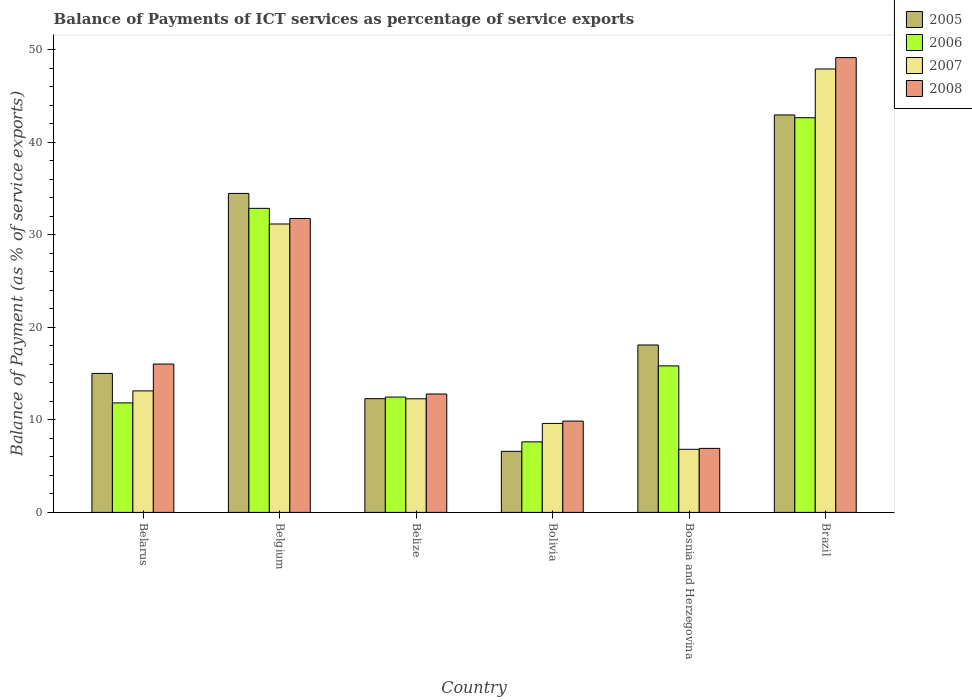How many groups of bars are there?
Provide a succinct answer. 6. How many bars are there on the 4th tick from the left?
Give a very brief answer. 4. How many bars are there on the 3rd tick from the right?
Keep it short and to the point. 4. What is the label of the 1st group of bars from the left?
Your answer should be very brief. Belarus. In how many cases, is the number of bars for a given country not equal to the number of legend labels?
Make the answer very short. 0. What is the balance of payments of ICT services in 2005 in Bosnia and Herzegovina?
Your response must be concise. 18.1. Across all countries, what is the maximum balance of payments of ICT services in 2006?
Make the answer very short. 42.67. Across all countries, what is the minimum balance of payments of ICT services in 2008?
Ensure brevity in your answer.  6.92. In which country was the balance of payments of ICT services in 2005 maximum?
Give a very brief answer. Brazil. In which country was the balance of payments of ICT services in 2005 minimum?
Make the answer very short. Bolivia. What is the total balance of payments of ICT services in 2008 in the graph?
Offer a terse response. 126.57. What is the difference between the balance of payments of ICT services in 2008 in Bosnia and Herzegovina and that in Brazil?
Provide a short and direct response. -42.25. What is the difference between the balance of payments of ICT services in 2007 in Belarus and the balance of payments of ICT services in 2005 in Brazil?
Offer a terse response. -29.83. What is the average balance of payments of ICT services in 2006 per country?
Keep it short and to the point. 20.55. What is the difference between the balance of payments of ICT services of/in 2008 and balance of payments of ICT services of/in 2005 in Belize?
Your response must be concise. 0.5. In how many countries, is the balance of payments of ICT services in 2005 greater than 28 %?
Make the answer very short. 2. What is the ratio of the balance of payments of ICT services in 2008 in Belarus to that in Bolivia?
Give a very brief answer. 1.62. What is the difference between the highest and the second highest balance of payments of ICT services in 2005?
Provide a short and direct response. 24.87. What is the difference between the highest and the lowest balance of payments of ICT services in 2006?
Keep it short and to the point. 35.04. In how many countries, is the balance of payments of ICT services in 2008 greater than the average balance of payments of ICT services in 2008 taken over all countries?
Your answer should be very brief. 2. Is it the case that in every country, the sum of the balance of payments of ICT services in 2008 and balance of payments of ICT services in 2007 is greater than the balance of payments of ICT services in 2006?
Offer a very short reply. No. How many bars are there?
Your response must be concise. 24. How many countries are there in the graph?
Make the answer very short. 6. Does the graph contain grids?
Your answer should be very brief. No. How many legend labels are there?
Offer a terse response. 4. How are the legend labels stacked?
Give a very brief answer. Vertical. What is the title of the graph?
Provide a succinct answer. Balance of Payments of ICT services as percentage of service exports. What is the label or title of the X-axis?
Give a very brief answer. Country. What is the label or title of the Y-axis?
Offer a very short reply. Balance of Payment (as % of service exports). What is the Balance of Payment (as % of service exports) of 2005 in Belarus?
Ensure brevity in your answer.  15.02. What is the Balance of Payment (as % of service exports) in 2006 in Belarus?
Your answer should be very brief. 11.84. What is the Balance of Payment (as % of service exports) of 2007 in Belarus?
Your response must be concise. 13.14. What is the Balance of Payment (as % of service exports) of 2008 in Belarus?
Offer a very short reply. 16.04. What is the Balance of Payment (as % of service exports) of 2005 in Belgium?
Offer a very short reply. 34.48. What is the Balance of Payment (as % of service exports) in 2006 in Belgium?
Offer a very short reply. 32.87. What is the Balance of Payment (as % of service exports) of 2007 in Belgium?
Offer a very short reply. 31.18. What is the Balance of Payment (as % of service exports) of 2008 in Belgium?
Keep it short and to the point. 31.77. What is the Balance of Payment (as % of service exports) in 2005 in Belize?
Provide a short and direct response. 12.29. What is the Balance of Payment (as % of service exports) in 2006 in Belize?
Your answer should be compact. 12.47. What is the Balance of Payment (as % of service exports) of 2007 in Belize?
Give a very brief answer. 12.28. What is the Balance of Payment (as % of service exports) in 2008 in Belize?
Make the answer very short. 12.8. What is the Balance of Payment (as % of service exports) of 2005 in Bolivia?
Ensure brevity in your answer.  6.6. What is the Balance of Payment (as % of service exports) of 2006 in Bolivia?
Give a very brief answer. 7.63. What is the Balance of Payment (as % of service exports) in 2007 in Bolivia?
Make the answer very short. 9.62. What is the Balance of Payment (as % of service exports) in 2008 in Bolivia?
Offer a terse response. 9.87. What is the Balance of Payment (as % of service exports) in 2005 in Bosnia and Herzegovina?
Provide a succinct answer. 18.1. What is the Balance of Payment (as % of service exports) in 2006 in Bosnia and Herzegovina?
Your response must be concise. 15.84. What is the Balance of Payment (as % of service exports) in 2007 in Bosnia and Herzegovina?
Keep it short and to the point. 6.82. What is the Balance of Payment (as % of service exports) in 2008 in Bosnia and Herzegovina?
Your answer should be very brief. 6.92. What is the Balance of Payment (as % of service exports) in 2005 in Brazil?
Offer a very short reply. 42.97. What is the Balance of Payment (as % of service exports) of 2006 in Brazil?
Ensure brevity in your answer.  42.67. What is the Balance of Payment (as % of service exports) of 2007 in Brazil?
Your answer should be very brief. 47.94. What is the Balance of Payment (as % of service exports) in 2008 in Brazil?
Offer a terse response. 49.17. Across all countries, what is the maximum Balance of Payment (as % of service exports) in 2005?
Offer a terse response. 42.97. Across all countries, what is the maximum Balance of Payment (as % of service exports) in 2006?
Provide a succinct answer. 42.67. Across all countries, what is the maximum Balance of Payment (as % of service exports) in 2007?
Provide a succinct answer. 47.94. Across all countries, what is the maximum Balance of Payment (as % of service exports) of 2008?
Your answer should be compact. 49.17. Across all countries, what is the minimum Balance of Payment (as % of service exports) in 2005?
Your answer should be very brief. 6.6. Across all countries, what is the minimum Balance of Payment (as % of service exports) of 2006?
Your answer should be very brief. 7.63. Across all countries, what is the minimum Balance of Payment (as % of service exports) in 2007?
Offer a very short reply. 6.82. Across all countries, what is the minimum Balance of Payment (as % of service exports) in 2008?
Your answer should be very brief. 6.92. What is the total Balance of Payment (as % of service exports) of 2005 in the graph?
Make the answer very short. 129.47. What is the total Balance of Payment (as % of service exports) of 2006 in the graph?
Your response must be concise. 123.31. What is the total Balance of Payment (as % of service exports) in 2007 in the graph?
Provide a short and direct response. 120.98. What is the total Balance of Payment (as % of service exports) of 2008 in the graph?
Offer a terse response. 126.57. What is the difference between the Balance of Payment (as % of service exports) in 2005 in Belarus and that in Belgium?
Offer a very short reply. -19.46. What is the difference between the Balance of Payment (as % of service exports) in 2006 in Belarus and that in Belgium?
Your response must be concise. -21.03. What is the difference between the Balance of Payment (as % of service exports) in 2007 in Belarus and that in Belgium?
Provide a short and direct response. -18.04. What is the difference between the Balance of Payment (as % of service exports) in 2008 in Belarus and that in Belgium?
Your answer should be compact. -15.73. What is the difference between the Balance of Payment (as % of service exports) in 2005 in Belarus and that in Belize?
Your answer should be very brief. 2.73. What is the difference between the Balance of Payment (as % of service exports) of 2006 in Belarus and that in Belize?
Offer a very short reply. -0.63. What is the difference between the Balance of Payment (as % of service exports) in 2007 in Belarus and that in Belize?
Make the answer very short. 0.85. What is the difference between the Balance of Payment (as % of service exports) in 2008 in Belarus and that in Belize?
Make the answer very short. 3.24. What is the difference between the Balance of Payment (as % of service exports) of 2005 in Belarus and that in Bolivia?
Your answer should be very brief. 8.42. What is the difference between the Balance of Payment (as % of service exports) of 2006 in Belarus and that in Bolivia?
Ensure brevity in your answer.  4.21. What is the difference between the Balance of Payment (as % of service exports) in 2007 in Belarus and that in Bolivia?
Offer a very short reply. 3.52. What is the difference between the Balance of Payment (as % of service exports) in 2008 in Belarus and that in Bolivia?
Make the answer very short. 6.17. What is the difference between the Balance of Payment (as % of service exports) of 2005 in Belarus and that in Bosnia and Herzegovina?
Offer a very short reply. -3.08. What is the difference between the Balance of Payment (as % of service exports) of 2006 in Belarus and that in Bosnia and Herzegovina?
Your response must be concise. -4. What is the difference between the Balance of Payment (as % of service exports) of 2007 in Belarus and that in Bosnia and Herzegovina?
Provide a short and direct response. 6.32. What is the difference between the Balance of Payment (as % of service exports) in 2008 in Belarus and that in Bosnia and Herzegovina?
Your response must be concise. 9.12. What is the difference between the Balance of Payment (as % of service exports) in 2005 in Belarus and that in Brazil?
Provide a succinct answer. -27.95. What is the difference between the Balance of Payment (as % of service exports) of 2006 in Belarus and that in Brazil?
Your answer should be very brief. -30.83. What is the difference between the Balance of Payment (as % of service exports) in 2007 in Belarus and that in Brazil?
Make the answer very short. -34.8. What is the difference between the Balance of Payment (as % of service exports) in 2008 in Belarus and that in Brazil?
Ensure brevity in your answer.  -33.13. What is the difference between the Balance of Payment (as % of service exports) of 2005 in Belgium and that in Belize?
Your response must be concise. 22.19. What is the difference between the Balance of Payment (as % of service exports) in 2006 in Belgium and that in Belize?
Provide a short and direct response. 20.4. What is the difference between the Balance of Payment (as % of service exports) of 2007 in Belgium and that in Belize?
Offer a very short reply. 18.9. What is the difference between the Balance of Payment (as % of service exports) of 2008 in Belgium and that in Belize?
Provide a succinct answer. 18.97. What is the difference between the Balance of Payment (as % of service exports) in 2005 in Belgium and that in Bolivia?
Keep it short and to the point. 27.88. What is the difference between the Balance of Payment (as % of service exports) in 2006 in Belgium and that in Bolivia?
Provide a succinct answer. 25.24. What is the difference between the Balance of Payment (as % of service exports) in 2007 in Belgium and that in Bolivia?
Make the answer very short. 21.56. What is the difference between the Balance of Payment (as % of service exports) of 2008 in Belgium and that in Bolivia?
Provide a succinct answer. 21.9. What is the difference between the Balance of Payment (as % of service exports) in 2005 in Belgium and that in Bosnia and Herzegovina?
Make the answer very short. 16.39. What is the difference between the Balance of Payment (as % of service exports) of 2006 in Belgium and that in Bosnia and Herzegovina?
Your answer should be very brief. 17.03. What is the difference between the Balance of Payment (as % of service exports) in 2007 in Belgium and that in Bosnia and Herzegovina?
Provide a succinct answer. 24.36. What is the difference between the Balance of Payment (as % of service exports) of 2008 in Belgium and that in Bosnia and Herzegovina?
Provide a succinct answer. 24.85. What is the difference between the Balance of Payment (as % of service exports) in 2005 in Belgium and that in Brazil?
Offer a very short reply. -8.49. What is the difference between the Balance of Payment (as % of service exports) of 2006 in Belgium and that in Brazil?
Provide a short and direct response. -9.8. What is the difference between the Balance of Payment (as % of service exports) in 2007 in Belgium and that in Brazil?
Ensure brevity in your answer.  -16.76. What is the difference between the Balance of Payment (as % of service exports) in 2008 in Belgium and that in Brazil?
Offer a terse response. -17.39. What is the difference between the Balance of Payment (as % of service exports) in 2005 in Belize and that in Bolivia?
Keep it short and to the point. 5.69. What is the difference between the Balance of Payment (as % of service exports) of 2006 in Belize and that in Bolivia?
Give a very brief answer. 4.84. What is the difference between the Balance of Payment (as % of service exports) in 2007 in Belize and that in Bolivia?
Provide a short and direct response. 2.66. What is the difference between the Balance of Payment (as % of service exports) of 2008 in Belize and that in Bolivia?
Offer a very short reply. 2.93. What is the difference between the Balance of Payment (as % of service exports) in 2005 in Belize and that in Bosnia and Herzegovina?
Offer a very short reply. -5.81. What is the difference between the Balance of Payment (as % of service exports) of 2006 in Belize and that in Bosnia and Herzegovina?
Provide a succinct answer. -3.37. What is the difference between the Balance of Payment (as % of service exports) of 2007 in Belize and that in Bosnia and Herzegovina?
Ensure brevity in your answer.  5.46. What is the difference between the Balance of Payment (as % of service exports) of 2008 in Belize and that in Bosnia and Herzegovina?
Give a very brief answer. 5.88. What is the difference between the Balance of Payment (as % of service exports) in 2005 in Belize and that in Brazil?
Offer a very short reply. -30.68. What is the difference between the Balance of Payment (as % of service exports) of 2006 in Belize and that in Brazil?
Your answer should be very brief. -30.2. What is the difference between the Balance of Payment (as % of service exports) of 2007 in Belize and that in Brazil?
Ensure brevity in your answer.  -35.65. What is the difference between the Balance of Payment (as % of service exports) in 2008 in Belize and that in Brazil?
Your answer should be very brief. -36.37. What is the difference between the Balance of Payment (as % of service exports) of 2005 in Bolivia and that in Bosnia and Herzegovina?
Provide a succinct answer. -11.5. What is the difference between the Balance of Payment (as % of service exports) in 2006 in Bolivia and that in Bosnia and Herzegovina?
Ensure brevity in your answer.  -8.21. What is the difference between the Balance of Payment (as % of service exports) of 2007 in Bolivia and that in Bosnia and Herzegovina?
Your answer should be very brief. 2.8. What is the difference between the Balance of Payment (as % of service exports) in 2008 in Bolivia and that in Bosnia and Herzegovina?
Your answer should be very brief. 2.95. What is the difference between the Balance of Payment (as % of service exports) of 2005 in Bolivia and that in Brazil?
Your response must be concise. -36.37. What is the difference between the Balance of Payment (as % of service exports) in 2006 in Bolivia and that in Brazil?
Offer a terse response. -35.04. What is the difference between the Balance of Payment (as % of service exports) in 2007 in Bolivia and that in Brazil?
Keep it short and to the point. -38.32. What is the difference between the Balance of Payment (as % of service exports) in 2008 in Bolivia and that in Brazil?
Your answer should be very brief. -39.3. What is the difference between the Balance of Payment (as % of service exports) in 2005 in Bosnia and Herzegovina and that in Brazil?
Give a very brief answer. -24.87. What is the difference between the Balance of Payment (as % of service exports) in 2006 in Bosnia and Herzegovina and that in Brazil?
Ensure brevity in your answer.  -26.83. What is the difference between the Balance of Payment (as % of service exports) in 2007 in Bosnia and Herzegovina and that in Brazil?
Offer a very short reply. -41.12. What is the difference between the Balance of Payment (as % of service exports) in 2008 in Bosnia and Herzegovina and that in Brazil?
Give a very brief answer. -42.25. What is the difference between the Balance of Payment (as % of service exports) in 2005 in Belarus and the Balance of Payment (as % of service exports) in 2006 in Belgium?
Offer a very short reply. -17.85. What is the difference between the Balance of Payment (as % of service exports) in 2005 in Belarus and the Balance of Payment (as % of service exports) in 2007 in Belgium?
Keep it short and to the point. -16.16. What is the difference between the Balance of Payment (as % of service exports) of 2005 in Belarus and the Balance of Payment (as % of service exports) of 2008 in Belgium?
Give a very brief answer. -16.75. What is the difference between the Balance of Payment (as % of service exports) in 2006 in Belarus and the Balance of Payment (as % of service exports) in 2007 in Belgium?
Your answer should be very brief. -19.34. What is the difference between the Balance of Payment (as % of service exports) in 2006 in Belarus and the Balance of Payment (as % of service exports) in 2008 in Belgium?
Offer a terse response. -19.93. What is the difference between the Balance of Payment (as % of service exports) of 2007 in Belarus and the Balance of Payment (as % of service exports) of 2008 in Belgium?
Offer a terse response. -18.64. What is the difference between the Balance of Payment (as % of service exports) in 2005 in Belarus and the Balance of Payment (as % of service exports) in 2006 in Belize?
Your response must be concise. 2.55. What is the difference between the Balance of Payment (as % of service exports) of 2005 in Belarus and the Balance of Payment (as % of service exports) of 2007 in Belize?
Your answer should be compact. 2.74. What is the difference between the Balance of Payment (as % of service exports) of 2005 in Belarus and the Balance of Payment (as % of service exports) of 2008 in Belize?
Provide a short and direct response. 2.23. What is the difference between the Balance of Payment (as % of service exports) of 2006 in Belarus and the Balance of Payment (as % of service exports) of 2007 in Belize?
Provide a short and direct response. -0.44. What is the difference between the Balance of Payment (as % of service exports) of 2006 in Belarus and the Balance of Payment (as % of service exports) of 2008 in Belize?
Make the answer very short. -0.96. What is the difference between the Balance of Payment (as % of service exports) of 2007 in Belarus and the Balance of Payment (as % of service exports) of 2008 in Belize?
Make the answer very short. 0.34. What is the difference between the Balance of Payment (as % of service exports) in 2005 in Belarus and the Balance of Payment (as % of service exports) in 2006 in Bolivia?
Ensure brevity in your answer.  7.4. What is the difference between the Balance of Payment (as % of service exports) of 2005 in Belarus and the Balance of Payment (as % of service exports) of 2007 in Bolivia?
Ensure brevity in your answer.  5.4. What is the difference between the Balance of Payment (as % of service exports) in 2005 in Belarus and the Balance of Payment (as % of service exports) in 2008 in Bolivia?
Provide a succinct answer. 5.15. What is the difference between the Balance of Payment (as % of service exports) of 2006 in Belarus and the Balance of Payment (as % of service exports) of 2007 in Bolivia?
Your answer should be very brief. 2.22. What is the difference between the Balance of Payment (as % of service exports) in 2006 in Belarus and the Balance of Payment (as % of service exports) in 2008 in Bolivia?
Your response must be concise. 1.97. What is the difference between the Balance of Payment (as % of service exports) in 2007 in Belarus and the Balance of Payment (as % of service exports) in 2008 in Bolivia?
Your answer should be very brief. 3.27. What is the difference between the Balance of Payment (as % of service exports) of 2005 in Belarus and the Balance of Payment (as % of service exports) of 2006 in Bosnia and Herzegovina?
Make the answer very short. -0.82. What is the difference between the Balance of Payment (as % of service exports) of 2005 in Belarus and the Balance of Payment (as % of service exports) of 2007 in Bosnia and Herzegovina?
Offer a terse response. 8.2. What is the difference between the Balance of Payment (as % of service exports) of 2005 in Belarus and the Balance of Payment (as % of service exports) of 2008 in Bosnia and Herzegovina?
Your response must be concise. 8.1. What is the difference between the Balance of Payment (as % of service exports) of 2006 in Belarus and the Balance of Payment (as % of service exports) of 2007 in Bosnia and Herzegovina?
Your answer should be very brief. 5.02. What is the difference between the Balance of Payment (as % of service exports) of 2006 in Belarus and the Balance of Payment (as % of service exports) of 2008 in Bosnia and Herzegovina?
Keep it short and to the point. 4.92. What is the difference between the Balance of Payment (as % of service exports) in 2007 in Belarus and the Balance of Payment (as % of service exports) in 2008 in Bosnia and Herzegovina?
Give a very brief answer. 6.22. What is the difference between the Balance of Payment (as % of service exports) of 2005 in Belarus and the Balance of Payment (as % of service exports) of 2006 in Brazil?
Give a very brief answer. -27.64. What is the difference between the Balance of Payment (as % of service exports) of 2005 in Belarus and the Balance of Payment (as % of service exports) of 2007 in Brazil?
Offer a very short reply. -32.91. What is the difference between the Balance of Payment (as % of service exports) of 2005 in Belarus and the Balance of Payment (as % of service exports) of 2008 in Brazil?
Keep it short and to the point. -34.14. What is the difference between the Balance of Payment (as % of service exports) in 2006 in Belarus and the Balance of Payment (as % of service exports) in 2007 in Brazil?
Your answer should be very brief. -36.1. What is the difference between the Balance of Payment (as % of service exports) in 2006 in Belarus and the Balance of Payment (as % of service exports) in 2008 in Brazil?
Offer a very short reply. -37.33. What is the difference between the Balance of Payment (as % of service exports) in 2007 in Belarus and the Balance of Payment (as % of service exports) in 2008 in Brazil?
Offer a very short reply. -36.03. What is the difference between the Balance of Payment (as % of service exports) in 2005 in Belgium and the Balance of Payment (as % of service exports) in 2006 in Belize?
Offer a terse response. 22.02. What is the difference between the Balance of Payment (as % of service exports) of 2005 in Belgium and the Balance of Payment (as % of service exports) of 2007 in Belize?
Ensure brevity in your answer.  22.2. What is the difference between the Balance of Payment (as % of service exports) of 2005 in Belgium and the Balance of Payment (as % of service exports) of 2008 in Belize?
Your answer should be compact. 21.69. What is the difference between the Balance of Payment (as % of service exports) in 2006 in Belgium and the Balance of Payment (as % of service exports) in 2007 in Belize?
Offer a very short reply. 20.59. What is the difference between the Balance of Payment (as % of service exports) of 2006 in Belgium and the Balance of Payment (as % of service exports) of 2008 in Belize?
Provide a short and direct response. 20.07. What is the difference between the Balance of Payment (as % of service exports) in 2007 in Belgium and the Balance of Payment (as % of service exports) in 2008 in Belize?
Your answer should be compact. 18.38. What is the difference between the Balance of Payment (as % of service exports) of 2005 in Belgium and the Balance of Payment (as % of service exports) of 2006 in Bolivia?
Keep it short and to the point. 26.86. What is the difference between the Balance of Payment (as % of service exports) in 2005 in Belgium and the Balance of Payment (as % of service exports) in 2007 in Bolivia?
Give a very brief answer. 24.87. What is the difference between the Balance of Payment (as % of service exports) of 2005 in Belgium and the Balance of Payment (as % of service exports) of 2008 in Bolivia?
Ensure brevity in your answer.  24.61. What is the difference between the Balance of Payment (as % of service exports) in 2006 in Belgium and the Balance of Payment (as % of service exports) in 2007 in Bolivia?
Ensure brevity in your answer.  23.25. What is the difference between the Balance of Payment (as % of service exports) in 2006 in Belgium and the Balance of Payment (as % of service exports) in 2008 in Bolivia?
Make the answer very short. 23. What is the difference between the Balance of Payment (as % of service exports) in 2007 in Belgium and the Balance of Payment (as % of service exports) in 2008 in Bolivia?
Offer a very short reply. 21.31. What is the difference between the Balance of Payment (as % of service exports) of 2005 in Belgium and the Balance of Payment (as % of service exports) of 2006 in Bosnia and Herzegovina?
Your response must be concise. 18.65. What is the difference between the Balance of Payment (as % of service exports) of 2005 in Belgium and the Balance of Payment (as % of service exports) of 2007 in Bosnia and Herzegovina?
Your answer should be compact. 27.66. What is the difference between the Balance of Payment (as % of service exports) in 2005 in Belgium and the Balance of Payment (as % of service exports) in 2008 in Bosnia and Herzegovina?
Your response must be concise. 27.56. What is the difference between the Balance of Payment (as % of service exports) of 2006 in Belgium and the Balance of Payment (as % of service exports) of 2007 in Bosnia and Herzegovina?
Provide a succinct answer. 26.05. What is the difference between the Balance of Payment (as % of service exports) in 2006 in Belgium and the Balance of Payment (as % of service exports) in 2008 in Bosnia and Herzegovina?
Offer a very short reply. 25.95. What is the difference between the Balance of Payment (as % of service exports) of 2007 in Belgium and the Balance of Payment (as % of service exports) of 2008 in Bosnia and Herzegovina?
Keep it short and to the point. 24.26. What is the difference between the Balance of Payment (as % of service exports) of 2005 in Belgium and the Balance of Payment (as % of service exports) of 2006 in Brazil?
Your answer should be compact. -8.18. What is the difference between the Balance of Payment (as % of service exports) in 2005 in Belgium and the Balance of Payment (as % of service exports) in 2007 in Brazil?
Offer a very short reply. -13.45. What is the difference between the Balance of Payment (as % of service exports) of 2005 in Belgium and the Balance of Payment (as % of service exports) of 2008 in Brazil?
Ensure brevity in your answer.  -14.68. What is the difference between the Balance of Payment (as % of service exports) of 2006 in Belgium and the Balance of Payment (as % of service exports) of 2007 in Brazil?
Your response must be concise. -15.07. What is the difference between the Balance of Payment (as % of service exports) in 2006 in Belgium and the Balance of Payment (as % of service exports) in 2008 in Brazil?
Your answer should be very brief. -16.3. What is the difference between the Balance of Payment (as % of service exports) in 2007 in Belgium and the Balance of Payment (as % of service exports) in 2008 in Brazil?
Provide a short and direct response. -17.99. What is the difference between the Balance of Payment (as % of service exports) of 2005 in Belize and the Balance of Payment (as % of service exports) of 2006 in Bolivia?
Your answer should be compact. 4.67. What is the difference between the Balance of Payment (as % of service exports) in 2005 in Belize and the Balance of Payment (as % of service exports) in 2007 in Bolivia?
Your answer should be compact. 2.67. What is the difference between the Balance of Payment (as % of service exports) in 2005 in Belize and the Balance of Payment (as % of service exports) in 2008 in Bolivia?
Offer a very short reply. 2.42. What is the difference between the Balance of Payment (as % of service exports) of 2006 in Belize and the Balance of Payment (as % of service exports) of 2007 in Bolivia?
Your answer should be very brief. 2.85. What is the difference between the Balance of Payment (as % of service exports) in 2006 in Belize and the Balance of Payment (as % of service exports) in 2008 in Bolivia?
Provide a succinct answer. 2.6. What is the difference between the Balance of Payment (as % of service exports) in 2007 in Belize and the Balance of Payment (as % of service exports) in 2008 in Bolivia?
Ensure brevity in your answer.  2.41. What is the difference between the Balance of Payment (as % of service exports) of 2005 in Belize and the Balance of Payment (as % of service exports) of 2006 in Bosnia and Herzegovina?
Keep it short and to the point. -3.55. What is the difference between the Balance of Payment (as % of service exports) in 2005 in Belize and the Balance of Payment (as % of service exports) in 2007 in Bosnia and Herzegovina?
Give a very brief answer. 5.47. What is the difference between the Balance of Payment (as % of service exports) of 2005 in Belize and the Balance of Payment (as % of service exports) of 2008 in Bosnia and Herzegovina?
Provide a short and direct response. 5.37. What is the difference between the Balance of Payment (as % of service exports) in 2006 in Belize and the Balance of Payment (as % of service exports) in 2007 in Bosnia and Herzegovina?
Provide a succinct answer. 5.65. What is the difference between the Balance of Payment (as % of service exports) in 2006 in Belize and the Balance of Payment (as % of service exports) in 2008 in Bosnia and Herzegovina?
Your answer should be compact. 5.55. What is the difference between the Balance of Payment (as % of service exports) of 2007 in Belize and the Balance of Payment (as % of service exports) of 2008 in Bosnia and Herzegovina?
Your response must be concise. 5.36. What is the difference between the Balance of Payment (as % of service exports) in 2005 in Belize and the Balance of Payment (as % of service exports) in 2006 in Brazil?
Provide a short and direct response. -30.37. What is the difference between the Balance of Payment (as % of service exports) in 2005 in Belize and the Balance of Payment (as % of service exports) in 2007 in Brazil?
Make the answer very short. -35.64. What is the difference between the Balance of Payment (as % of service exports) of 2005 in Belize and the Balance of Payment (as % of service exports) of 2008 in Brazil?
Your answer should be compact. -36.87. What is the difference between the Balance of Payment (as % of service exports) in 2006 in Belize and the Balance of Payment (as % of service exports) in 2007 in Brazil?
Your answer should be very brief. -35.47. What is the difference between the Balance of Payment (as % of service exports) in 2006 in Belize and the Balance of Payment (as % of service exports) in 2008 in Brazil?
Make the answer very short. -36.7. What is the difference between the Balance of Payment (as % of service exports) of 2007 in Belize and the Balance of Payment (as % of service exports) of 2008 in Brazil?
Your answer should be compact. -36.88. What is the difference between the Balance of Payment (as % of service exports) of 2005 in Bolivia and the Balance of Payment (as % of service exports) of 2006 in Bosnia and Herzegovina?
Provide a succinct answer. -9.24. What is the difference between the Balance of Payment (as % of service exports) in 2005 in Bolivia and the Balance of Payment (as % of service exports) in 2007 in Bosnia and Herzegovina?
Make the answer very short. -0.22. What is the difference between the Balance of Payment (as % of service exports) in 2005 in Bolivia and the Balance of Payment (as % of service exports) in 2008 in Bosnia and Herzegovina?
Give a very brief answer. -0.32. What is the difference between the Balance of Payment (as % of service exports) in 2006 in Bolivia and the Balance of Payment (as % of service exports) in 2007 in Bosnia and Herzegovina?
Keep it short and to the point. 0.8. What is the difference between the Balance of Payment (as % of service exports) of 2006 in Bolivia and the Balance of Payment (as % of service exports) of 2008 in Bosnia and Herzegovina?
Make the answer very short. 0.71. What is the difference between the Balance of Payment (as % of service exports) of 2007 in Bolivia and the Balance of Payment (as % of service exports) of 2008 in Bosnia and Herzegovina?
Your response must be concise. 2.7. What is the difference between the Balance of Payment (as % of service exports) in 2005 in Bolivia and the Balance of Payment (as % of service exports) in 2006 in Brazil?
Provide a succinct answer. -36.07. What is the difference between the Balance of Payment (as % of service exports) in 2005 in Bolivia and the Balance of Payment (as % of service exports) in 2007 in Brazil?
Your answer should be compact. -41.34. What is the difference between the Balance of Payment (as % of service exports) of 2005 in Bolivia and the Balance of Payment (as % of service exports) of 2008 in Brazil?
Keep it short and to the point. -42.57. What is the difference between the Balance of Payment (as % of service exports) of 2006 in Bolivia and the Balance of Payment (as % of service exports) of 2007 in Brazil?
Make the answer very short. -40.31. What is the difference between the Balance of Payment (as % of service exports) in 2006 in Bolivia and the Balance of Payment (as % of service exports) in 2008 in Brazil?
Ensure brevity in your answer.  -41.54. What is the difference between the Balance of Payment (as % of service exports) in 2007 in Bolivia and the Balance of Payment (as % of service exports) in 2008 in Brazil?
Make the answer very short. -39.55. What is the difference between the Balance of Payment (as % of service exports) of 2005 in Bosnia and Herzegovina and the Balance of Payment (as % of service exports) of 2006 in Brazil?
Your response must be concise. -24.57. What is the difference between the Balance of Payment (as % of service exports) of 2005 in Bosnia and Herzegovina and the Balance of Payment (as % of service exports) of 2007 in Brazil?
Make the answer very short. -29.84. What is the difference between the Balance of Payment (as % of service exports) in 2005 in Bosnia and Herzegovina and the Balance of Payment (as % of service exports) in 2008 in Brazil?
Your response must be concise. -31.07. What is the difference between the Balance of Payment (as % of service exports) of 2006 in Bosnia and Herzegovina and the Balance of Payment (as % of service exports) of 2007 in Brazil?
Make the answer very short. -32.1. What is the difference between the Balance of Payment (as % of service exports) in 2006 in Bosnia and Herzegovina and the Balance of Payment (as % of service exports) in 2008 in Brazil?
Offer a very short reply. -33.33. What is the difference between the Balance of Payment (as % of service exports) of 2007 in Bosnia and Herzegovina and the Balance of Payment (as % of service exports) of 2008 in Brazil?
Offer a terse response. -42.34. What is the average Balance of Payment (as % of service exports) of 2005 per country?
Ensure brevity in your answer.  21.58. What is the average Balance of Payment (as % of service exports) in 2006 per country?
Keep it short and to the point. 20.55. What is the average Balance of Payment (as % of service exports) of 2007 per country?
Your answer should be very brief. 20.16. What is the average Balance of Payment (as % of service exports) of 2008 per country?
Provide a short and direct response. 21.09. What is the difference between the Balance of Payment (as % of service exports) of 2005 and Balance of Payment (as % of service exports) of 2006 in Belarus?
Offer a very short reply. 3.19. What is the difference between the Balance of Payment (as % of service exports) of 2005 and Balance of Payment (as % of service exports) of 2007 in Belarus?
Your response must be concise. 1.89. What is the difference between the Balance of Payment (as % of service exports) in 2005 and Balance of Payment (as % of service exports) in 2008 in Belarus?
Provide a short and direct response. -1.01. What is the difference between the Balance of Payment (as % of service exports) in 2006 and Balance of Payment (as % of service exports) in 2007 in Belarus?
Keep it short and to the point. -1.3. What is the difference between the Balance of Payment (as % of service exports) of 2006 and Balance of Payment (as % of service exports) of 2008 in Belarus?
Your answer should be compact. -4.2. What is the difference between the Balance of Payment (as % of service exports) of 2007 and Balance of Payment (as % of service exports) of 2008 in Belarus?
Your response must be concise. -2.9. What is the difference between the Balance of Payment (as % of service exports) in 2005 and Balance of Payment (as % of service exports) in 2006 in Belgium?
Your answer should be very brief. 1.61. What is the difference between the Balance of Payment (as % of service exports) in 2005 and Balance of Payment (as % of service exports) in 2007 in Belgium?
Ensure brevity in your answer.  3.31. What is the difference between the Balance of Payment (as % of service exports) in 2005 and Balance of Payment (as % of service exports) in 2008 in Belgium?
Your answer should be very brief. 2.71. What is the difference between the Balance of Payment (as % of service exports) of 2006 and Balance of Payment (as % of service exports) of 2007 in Belgium?
Your response must be concise. 1.69. What is the difference between the Balance of Payment (as % of service exports) of 2006 and Balance of Payment (as % of service exports) of 2008 in Belgium?
Ensure brevity in your answer.  1.1. What is the difference between the Balance of Payment (as % of service exports) in 2007 and Balance of Payment (as % of service exports) in 2008 in Belgium?
Provide a succinct answer. -0.59. What is the difference between the Balance of Payment (as % of service exports) of 2005 and Balance of Payment (as % of service exports) of 2006 in Belize?
Provide a short and direct response. -0.18. What is the difference between the Balance of Payment (as % of service exports) in 2005 and Balance of Payment (as % of service exports) in 2007 in Belize?
Keep it short and to the point. 0.01. What is the difference between the Balance of Payment (as % of service exports) in 2005 and Balance of Payment (as % of service exports) in 2008 in Belize?
Provide a short and direct response. -0.5. What is the difference between the Balance of Payment (as % of service exports) in 2006 and Balance of Payment (as % of service exports) in 2007 in Belize?
Your answer should be compact. 0.19. What is the difference between the Balance of Payment (as % of service exports) in 2006 and Balance of Payment (as % of service exports) in 2008 in Belize?
Provide a short and direct response. -0.33. What is the difference between the Balance of Payment (as % of service exports) of 2007 and Balance of Payment (as % of service exports) of 2008 in Belize?
Offer a very short reply. -0.52. What is the difference between the Balance of Payment (as % of service exports) in 2005 and Balance of Payment (as % of service exports) in 2006 in Bolivia?
Offer a very short reply. -1.03. What is the difference between the Balance of Payment (as % of service exports) of 2005 and Balance of Payment (as % of service exports) of 2007 in Bolivia?
Offer a terse response. -3.02. What is the difference between the Balance of Payment (as % of service exports) of 2005 and Balance of Payment (as % of service exports) of 2008 in Bolivia?
Your answer should be compact. -3.27. What is the difference between the Balance of Payment (as % of service exports) of 2006 and Balance of Payment (as % of service exports) of 2007 in Bolivia?
Give a very brief answer. -1.99. What is the difference between the Balance of Payment (as % of service exports) in 2006 and Balance of Payment (as % of service exports) in 2008 in Bolivia?
Your response must be concise. -2.24. What is the difference between the Balance of Payment (as % of service exports) in 2007 and Balance of Payment (as % of service exports) in 2008 in Bolivia?
Offer a very short reply. -0.25. What is the difference between the Balance of Payment (as % of service exports) of 2005 and Balance of Payment (as % of service exports) of 2006 in Bosnia and Herzegovina?
Give a very brief answer. 2.26. What is the difference between the Balance of Payment (as % of service exports) of 2005 and Balance of Payment (as % of service exports) of 2007 in Bosnia and Herzegovina?
Provide a short and direct response. 11.28. What is the difference between the Balance of Payment (as % of service exports) in 2005 and Balance of Payment (as % of service exports) in 2008 in Bosnia and Herzegovina?
Give a very brief answer. 11.18. What is the difference between the Balance of Payment (as % of service exports) in 2006 and Balance of Payment (as % of service exports) in 2007 in Bosnia and Herzegovina?
Your answer should be compact. 9.02. What is the difference between the Balance of Payment (as % of service exports) in 2006 and Balance of Payment (as % of service exports) in 2008 in Bosnia and Herzegovina?
Your response must be concise. 8.92. What is the difference between the Balance of Payment (as % of service exports) of 2007 and Balance of Payment (as % of service exports) of 2008 in Bosnia and Herzegovina?
Provide a succinct answer. -0.1. What is the difference between the Balance of Payment (as % of service exports) in 2005 and Balance of Payment (as % of service exports) in 2006 in Brazil?
Offer a terse response. 0.3. What is the difference between the Balance of Payment (as % of service exports) of 2005 and Balance of Payment (as % of service exports) of 2007 in Brazil?
Provide a short and direct response. -4.97. What is the difference between the Balance of Payment (as % of service exports) of 2005 and Balance of Payment (as % of service exports) of 2008 in Brazil?
Make the answer very short. -6.2. What is the difference between the Balance of Payment (as % of service exports) in 2006 and Balance of Payment (as % of service exports) in 2007 in Brazil?
Offer a terse response. -5.27. What is the difference between the Balance of Payment (as % of service exports) in 2006 and Balance of Payment (as % of service exports) in 2008 in Brazil?
Offer a very short reply. -6.5. What is the difference between the Balance of Payment (as % of service exports) of 2007 and Balance of Payment (as % of service exports) of 2008 in Brazil?
Offer a very short reply. -1.23. What is the ratio of the Balance of Payment (as % of service exports) in 2005 in Belarus to that in Belgium?
Your response must be concise. 0.44. What is the ratio of the Balance of Payment (as % of service exports) in 2006 in Belarus to that in Belgium?
Your answer should be very brief. 0.36. What is the ratio of the Balance of Payment (as % of service exports) of 2007 in Belarus to that in Belgium?
Offer a very short reply. 0.42. What is the ratio of the Balance of Payment (as % of service exports) of 2008 in Belarus to that in Belgium?
Give a very brief answer. 0.5. What is the ratio of the Balance of Payment (as % of service exports) in 2005 in Belarus to that in Belize?
Keep it short and to the point. 1.22. What is the ratio of the Balance of Payment (as % of service exports) in 2006 in Belarus to that in Belize?
Give a very brief answer. 0.95. What is the ratio of the Balance of Payment (as % of service exports) of 2007 in Belarus to that in Belize?
Give a very brief answer. 1.07. What is the ratio of the Balance of Payment (as % of service exports) in 2008 in Belarus to that in Belize?
Provide a succinct answer. 1.25. What is the ratio of the Balance of Payment (as % of service exports) of 2005 in Belarus to that in Bolivia?
Your answer should be compact. 2.28. What is the ratio of the Balance of Payment (as % of service exports) in 2006 in Belarus to that in Bolivia?
Keep it short and to the point. 1.55. What is the ratio of the Balance of Payment (as % of service exports) of 2007 in Belarus to that in Bolivia?
Offer a terse response. 1.37. What is the ratio of the Balance of Payment (as % of service exports) in 2008 in Belarus to that in Bolivia?
Keep it short and to the point. 1.62. What is the ratio of the Balance of Payment (as % of service exports) in 2005 in Belarus to that in Bosnia and Herzegovina?
Your answer should be very brief. 0.83. What is the ratio of the Balance of Payment (as % of service exports) in 2006 in Belarus to that in Bosnia and Herzegovina?
Your response must be concise. 0.75. What is the ratio of the Balance of Payment (as % of service exports) in 2007 in Belarus to that in Bosnia and Herzegovina?
Provide a succinct answer. 1.93. What is the ratio of the Balance of Payment (as % of service exports) of 2008 in Belarus to that in Bosnia and Herzegovina?
Provide a succinct answer. 2.32. What is the ratio of the Balance of Payment (as % of service exports) of 2005 in Belarus to that in Brazil?
Your response must be concise. 0.35. What is the ratio of the Balance of Payment (as % of service exports) of 2006 in Belarus to that in Brazil?
Your response must be concise. 0.28. What is the ratio of the Balance of Payment (as % of service exports) of 2007 in Belarus to that in Brazil?
Your response must be concise. 0.27. What is the ratio of the Balance of Payment (as % of service exports) of 2008 in Belarus to that in Brazil?
Offer a very short reply. 0.33. What is the ratio of the Balance of Payment (as % of service exports) of 2005 in Belgium to that in Belize?
Provide a short and direct response. 2.81. What is the ratio of the Balance of Payment (as % of service exports) in 2006 in Belgium to that in Belize?
Your answer should be very brief. 2.64. What is the ratio of the Balance of Payment (as % of service exports) in 2007 in Belgium to that in Belize?
Offer a very short reply. 2.54. What is the ratio of the Balance of Payment (as % of service exports) of 2008 in Belgium to that in Belize?
Keep it short and to the point. 2.48. What is the ratio of the Balance of Payment (as % of service exports) of 2005 in Belgium to that in Bolivia?
Provide a short and direct response. 5.22. What is the ratio of the Balance of Payment (as % of service exports) of 2006 in Belgium to that in Bolivia?
Your response must be concise. 4.31. What is the ratio of the Balance of Payment (as % of service exports) of 2007 in Belgium to that in Bolivia?
Give a very brief answer. 3.24. What is the ratio of the Balance of Payment (as % of service exports) in 2008 in Belgium to that in Bolivia?
Ensure brevity in your answer.  3.22. What is the ratio of the Balance of Payment (as % of service exports) of 2005 in Belgium to that in Bosnia and Herzegovina?
Give a very brief answer. 1.91. What is the ratio of the Balance of Payment (as % of service exports) of 2006 in Belgium to that in Bosnia and Herzegovina?
Provide a succinct answer. 2.08. What is the ratio of the Balance of Payment (as % of service exports) of 2007 in Belgium to that in Bosnia and Herzegovina?
Your response must be concise. 4.57. What is the ratio of the Balance of Payment (as % of service exports) of 2008 in Belgium to that in Bosnia and Herzegovina?
Offer a very short reply. 4.59. What is the ratio of the Balance of Payment (as % of service exports) of 2005 in Belgium to that in Brazil?
Your answer should be very brief. 0.8. What is the ratio of the Balance of Payment (as % of service exports) in 2006 in Belgium to that in Brazil?
Make the answer very short. 0.77. What is the ratio of the Balance of Payment (as % of service exports) of 2007 in Belgium to that in Brazil?
Your response must be concise. 0.65. What is the ratio of the Balance of Payment (as % of service exports) in 2008 in Belgium to that in Brazil?
Ensure brevity in your answer.  0.65. What is the ratio of the Balance of Payment (as % of service exports) in 2005 in Belize to that in Bolivia?
Give a very brief answer. 1.86. What is the ratio of the Balance of Payment (as % of service exports) of 2006 in Belize to that in Bolivia?
Offer a terse response. 1.64. What is the ratio of the Balance of Payment (as % of service exports) of 2007 in Belize to that in Bolivia?
Keep it short and to the point. 1.28. What is the ratio of the Balance of Payment (as % of service exports) in 2008 in Belize to that in Bolivia?
Your answer should be compact. 1.3. What is the ratio of the Balance of Payment (as % of service exports) of 2005 in Belize to that in Bosnia and Herzegovina?
Make the answer very short. 0.68. What is the ratio of the Balance of Payment (as % of service exports) of 2006 in Belize to that in Bosnia and Herzegovina?
Offer a very short reply. 0.79. What is the ratio of the Balance of Payment (as % of service exports) of 2007 in Belize to that in Bosnia and Herzegovina?
Offer a very short reply. 1.8. What is the ratio of the Balance of Payment (as % of service exports) of 2008 in Belize to that in Bosnia and Herzegovina?
Provide a short and direct response. 1.85. What is the ratio of the Balance of Payment (as % of service exports) of 2005 in Belize to that in Brazil?
Offer a terse response. 0.29. What is the ratio of the Balance of Payment (as % of service exports) in 2006 in Belize to that in Brazil?
Your answer should be very brief. 0.29. What is the ratio of the Balance of Payment (as % of service exports) of 2007 in Belize to that in Brazil?
Ensure brevity in your answer.  0.26. What is the ratio of the Balance of Payment (as % of service exports) in 2008 in Belize to that in Brazil?
Give a very brief answer. 0.26. What is the ratio of the Balance of Payment (as % of service exports) in 2005 in Bolivia to that in Bosnia and Herzegovina?
Offer a very short reply. 0.36. What is the ratio of the Balance of Payment (as % of service exports) in 2006 in Bolivia to that in Bosnia and Herzegovina?
Offer a terse response. 0.48. What is the ratio of the Balance of Payment (as % of service exports) of 2007 in Bolivia to that in Bosnia and Herzegovina?
Offer a very short reply. 1.41. What is the ratio of the Balance of Payment (as % of service exports) in 2008 in Bolivia to that in Bosnia and Herzegovina?
Offer a very short reply. 1.43. What is the ratio of the Balance of Payment (as % of service exports) of 2005 in Bolivia to that in Brazil?
Offer a very short reply. 0.15. What is the ratio of the Balance of Payment (as % of service exports) in 2006 in Bolivia to that in Brazil?
Your answer should be very brief. 0.18. What is the ratio of the Balance of Payment (as % of service exports) of 2007 in Bolivia to that in Brazil?
Your answer should be very brief. 0.2. What is the ratio of the Balance of Payment (as % of service exports) of 2008 in Bolivia to that in Brazil?
Offer a terse response. 0.2. What is the ratio of the Balance of Payment (as % of service exports) in 2005 in Bosnia and Herzegovina to that in Brazil?
Give a very brief answer. 0.42. What is the ratio of the Balance of Payment (as % of service exports) in 2006 in Bosnia and Herzegovina to that in Brazil?
Offer a terse response. 0.37. What is the ratio of the Balance of Payment (as % of service exports) in 2007 in Bosnia and Herzegovina to that in Brazil?
Your answer should be very brief. 0.14. What is the ratio of the Balance of Payment (as % of service exports) of 2008 in Bosnia and Herzegovina to that in Brazil?
Your answer should be very brief. 0.14. What is the difference between the highest and the second highest Balance of Payment (as % of service exports) in 2005?
Offer a very short reply. 8.49. What is the difference between the highest and the second highest Balance of Payment (as % of service exports) of 2006?
Ensure brevity in your answer.  9.8. What is the difference between the highest and the second highest Balance of Payment (as % of service exports) in 2007?
Keep it short and to the point. 16.76. What is the difference between the highest and the second highest Balance of Payment (as % of service exports) of 2008?
Your response must be concise. 17.39. What is the difference between the highest and the lowest Balance of Payment (as % of service exports) in 2005?
Provide a short and direct response. 36.37. What is the difference between the highest and the lowest Balance of Payment (as % of service exports) of 2006?
Your answer should be very brief. 35.04. What is the difference between the highest and the lowest Balance of Payment (as % of service exports) of 2007?
Provide a short and direct response. 41.12. What is the difference between the highest and the lowest Balance of Payment (as % of service exports) of 2008?
Your answer should be compact. 42.25. 